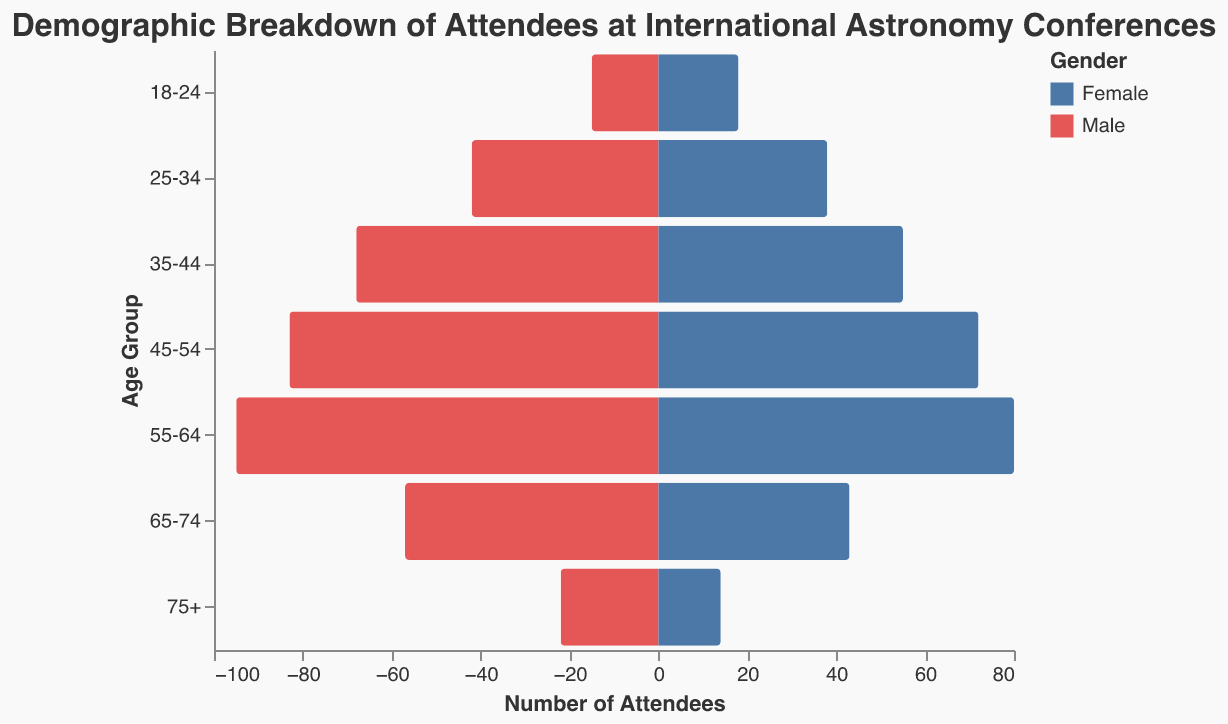What is the title of the figure? The title of the figure is displayed at the top, indicating the content of the chart.
Answer: Demographic Breakdown of Attendees at International Astronomy Conferences What age group has the largest number of male attendees? By examining the values on the x-axis, the largest bar toward the left, representing male attendees, belongs to a specific age group.
Answer: 55-64 Which gender has the majority in the 18-24 age group? Compare the lengths of the bars for each gender within the 18-24 age group to determine which one is longer.
Answer: Female How many total attendees are there in the 65-74 age group? Sum the number of male and female attendees in the 65-74 age group: 57 males + 43 females.
Answer: 100 Which age group has the smallest number of female attendees? Identify the age group with the shortest bar on the right side representing female attendees.
Answer: 75+ What is the difference in the number of attendees between the 45-54 and 55-64 age groups? Calculate the total attendees for 45-54 (83 males + 72 females) and 55-64 (95 males + 80 females) then find their difference: (95+80) - (83+72).
Answer: 20 Are there more attendees in the 35-44 or the 45-54 age group? Calculate the total attendees for both the 35-44 and the 45-54 age groups and compare their sums.
Answer: 45-54 What is the total number of female attendees across all age groups? Sum the number of female attendees for each age group: 18 + 38 + 55 + 72 + 80 + 43 + 14.
Answer: 320 Which age group has a male-to-female ratio closest to 1:1? Compare the male and female counts for each age group to find the ratios and identify which one is closest to 1:1.
Answer: 25-34 What percentage of attendees are in the 75+ age group? Sum the total number of attendees across all age groups and compare it to the total number in the 75+ age group: 22 males + 14 females = 36; total attendees = 15+18+42+38+68+55+83+72+95+80+57+43+22+14; then calculate the percentage (36/722) * 100.
Answer: ~4.99% 